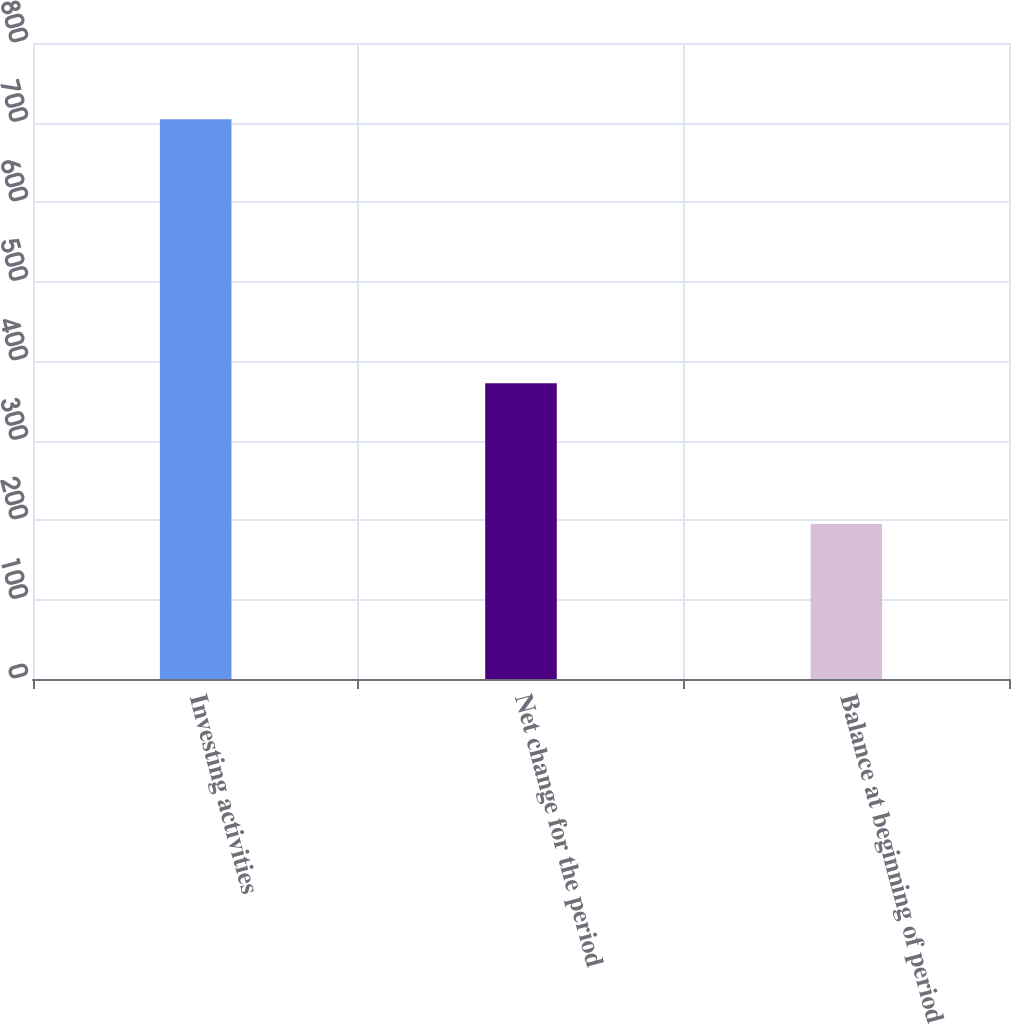<chart> <loc_0><loc_0><loc_500><loc_500><bar_chart><fcel>Investing activities<fcel>Net change for the period<fcel>Balance at beginning of period<nl><fcel>704<fcel>372<fcel>195<nl></chart> 